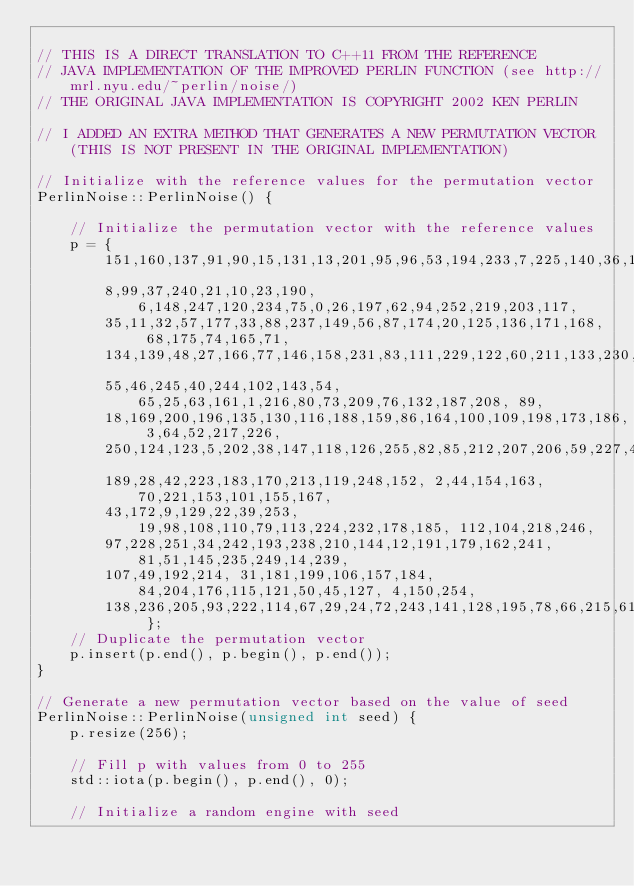Convert code to text. <code><loc_0><loc_0><loc_500><loc_500><_Cuda_>
// THIS IS A DIRECT TRANSLATION TO C++11 FROM THE REFERENCE
// JAVA IMPLEMENTATION OF THE IMPROVED PERLIN FUNCTION (see http://mrl.nyu.edu/~perlin/noise/)
// THE ORIGINAL JAVA IMPLEMENTATION IS COPYRIGHT 2002 KEN PERLIN

// I ADDED AN EXTRA METHOD THAT GENERATES A NEW PERMUTATION VECTOR (THIS IS NOT PRESENT IN THE ORIGINAL IMPLEMENTATION)

// Initialize with the reference values for the permutation vector
PerlinNoise::PerlinNoise() {
	
	// Initialize the permutation vector with the reference values
	p = {
		151,160,137,91,90,15,131,13,201,95,96,53,194,233,7,225,140,36,103,30,69,142,
		8,99,37,240,21,10,23,190, 6,148,247,120,234,75,0,26,197,62,94,252,219,203,117,
		35,11,32,57,177,33,88,237,149,56,87,174,20,125,136,171,168, 68,175,74,165,71,
		134,139,48,27,166,77,146,158,231,83,111,229,122,60,211,133,230,220,105,92,41,
		55,46,245,40,244,102,143,54, 65,25,63,161,1,216,80,73,209,76,132,187,208, 89,
		18,169,200,196,135,130,116,188,159,86,164,100,109,198,173,186, 3,64,52,217,226,
		250,124,123,5,202,38,147,118,126,255,82,85,212,207,206,59,227,47,16,58,17,182,
		189,28,42,223,183,170,213,119,248,152, 2,44,154,163, 70,221,153,101,155,167, 
		43,172,9,129,22,39,253, 19,98,108,110,79,113,224,232,178,185, 112,104,218,246,
		97,228,251,34,242,193,238,210,144,12,191,179,162,241, 81,51,145,235,249,14,239,
		107,49,192,214, 31,181,199,106,157,184, 84,204,176,115,121,50,45,127, 4,150,254,
		138,236,205,93,222,114,67,29,24,72,243,141,128,195,78,66,215,61,156,180 };
	// Duplicate the permutation vector
	p.insert(p.end(), p.begin(), p.end());
}

// Generate a new permutation vector based on the value of seed
PerlinNoise::PerlinNoise(unsigned int seed) {
	p.resize(256);

	// Fill p with values from 0 to 255
	std::iota(p.begin(), p.end(), 0);

	// Initialize a random engine with seed</code> 